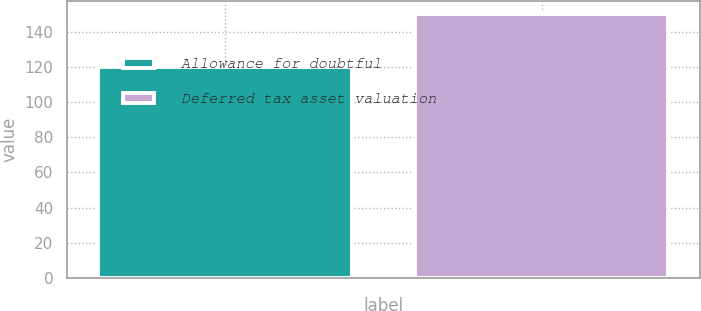<chart> <loc_0><loc_0><loc_500><loc_500><bar_chart><fcel>Allowance for doubtful<fcel>Deferred tax asset valuation<nl><fcel>120<fcel>150<nl></chart> 